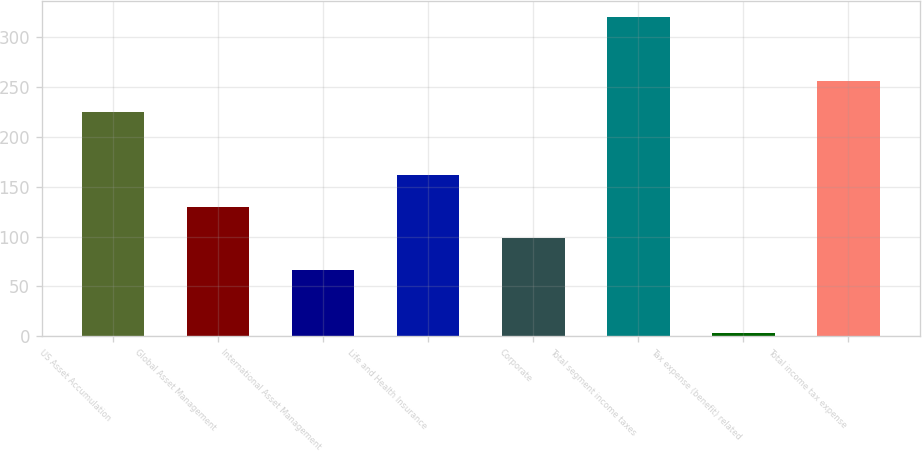Convert chart. <chart><loc_0><loc_0><loc_500><loc_500><bar_chart><fcel>US Asset Accumulation<fcel>Global Asset Management<fcel>International Asset Management<fcel>Life and Health Insurance<fcel>Corporate<fcel>Total segment income taxes<fcel>Tax expense (benefit) related<fcel>Total income tax expense<nl><fcel>224.76<fcel>129.72<fcel>66.36<fcel>161.4<fcel>98.04<fcel>319.8<fcel>3<fcel>256.44<nl></chart> 